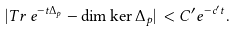<formula> <loc_0><loc_0><loc_500><loc_500>| T r \, e ^ { - t \Delta _ { p } } - \dim \ker \Delta _ { p } | \, < C ^ { \prime } e ^ { - c ^ { \prime } t } .</formula> 